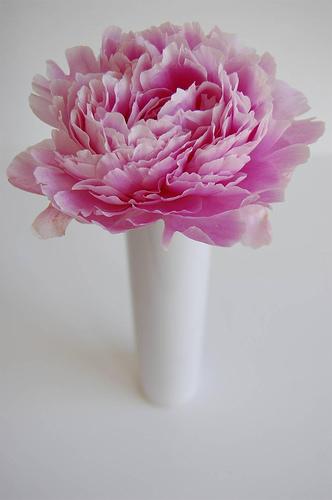What number of flowers are pink?
Keep it brief. 1. What color is the vase?
Be succinct. White. How many different types of flowers are in the vase?
Short answer required. 1. What kind of flower is show?
Short answer required. Carnation. How many flowers are in the vase?
Short answer required. 1. How many different objects are in this image?
Write a very short answer. 2. Where are the flowers?
Write a very short answer. In vase. What color vase is the pink flower in?
Write a very short answer. White. What color are the flowers?
Be succinct. Pink. Why do you think this might have sentimental value?
Short answer required. Romantic. What type of flowers are these?
Concise answer only. Carnation. 